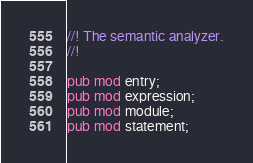<code> <loc_0><loc_0><loc_500><loc_500><_Rust_>//! The semantic analyzer.
//!

pub mod entry;
pub mod expression;
pub mod module;
pub mod statement;
</code> 